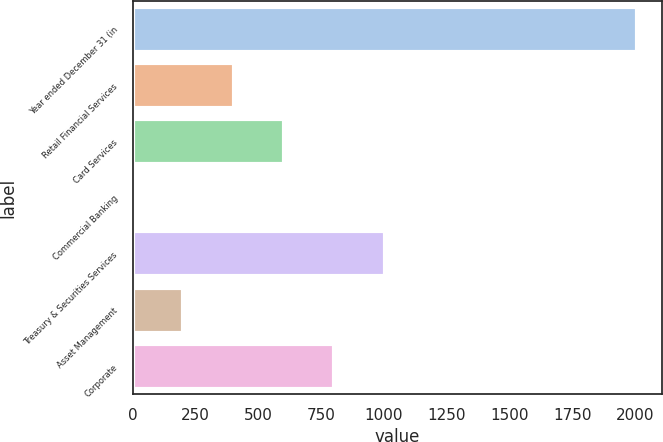<chart> <loc_0><loc_0><loc_500><loc_500><bar_chart><fcel>Year ended December 31 (in<fcel>Retail Financial Services<fcel>Card Services<fcel>Commercial Banking<fcel>Treasury & Securities Services<fcel>Asset Management<fcel>Corporate<nl><fcel>2006<fcel>402<fcel>602.5<fcel>1<fcel>1003.5<fcel>201.5<fcel>803<nl></chart> 